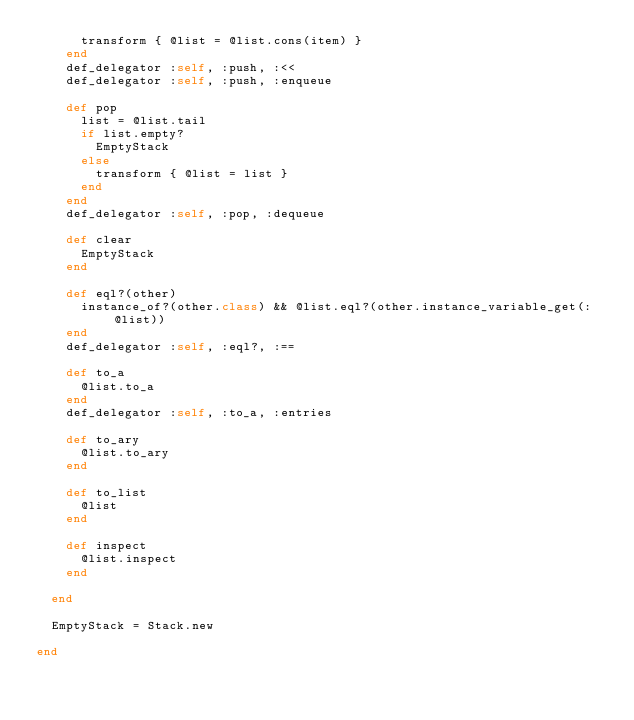<code> <loc_0><loc_0><loc_500><loc_500><_Ruby_>      transform { @list = @list.cons(item) }
    end
    def_delegator :self, :push, :<<
    def_delegator :self, :push, :enqueue

    def pop
      list = @list.tail
      if list.empty?
        EmptyStack
      else
        transform { @list = list }
      end
    end
    def_delegator :self, :pop, :dequeue

    def clear
      EmptyStack
    end

    def eql?(other)
      instance_of?(other.class) && @list.eql?(other.instance_variable_get(:@list))
    end
    def_delegator :self, :eql?, :==

    def to_a
      @list.to_a
    end
    def_delegator :self, :to_a, :entries

    def to_ary
      @list.to_ary
    end

    def to_list
      @list
    end

    def inspect
      @list.inspect
    end

  end

  EmptyStack = Stack.new

end
</code> 